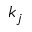<formula> <loc_0><loc_0><loc_500><loc_500>k _ { j }</formula> 